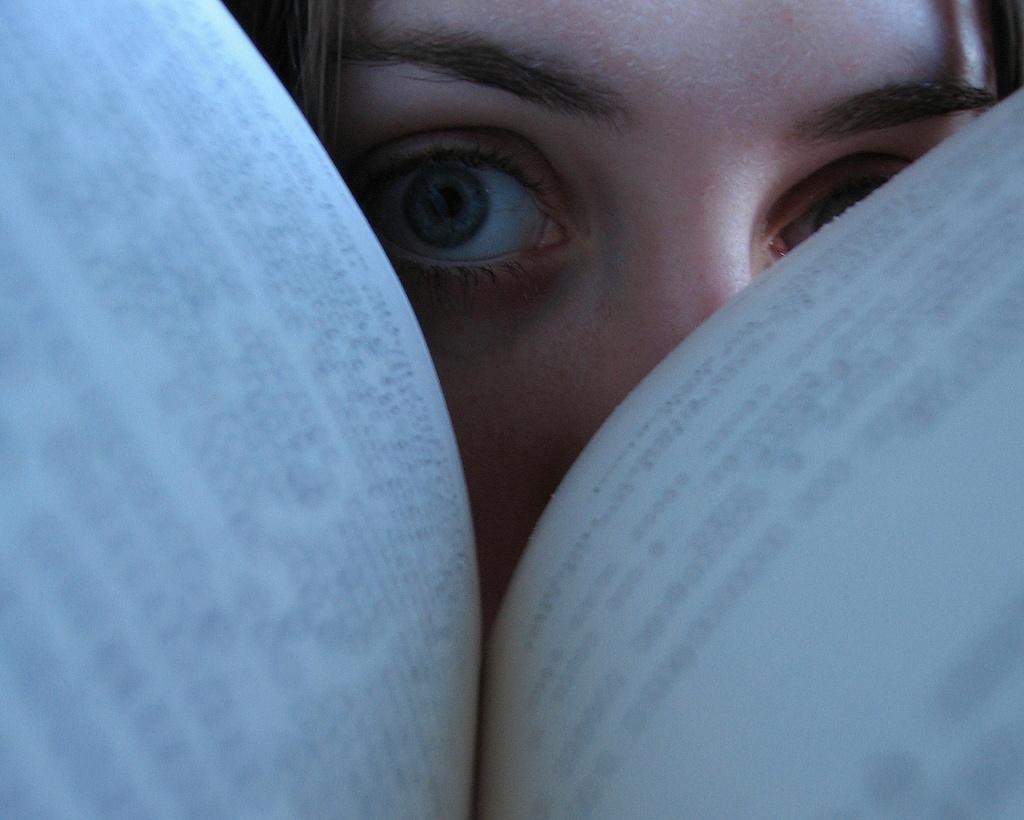Describe this image in one or two sentences. In this image I can see eyes of a woman. Here I can see two pages and on it I can see something is written. 